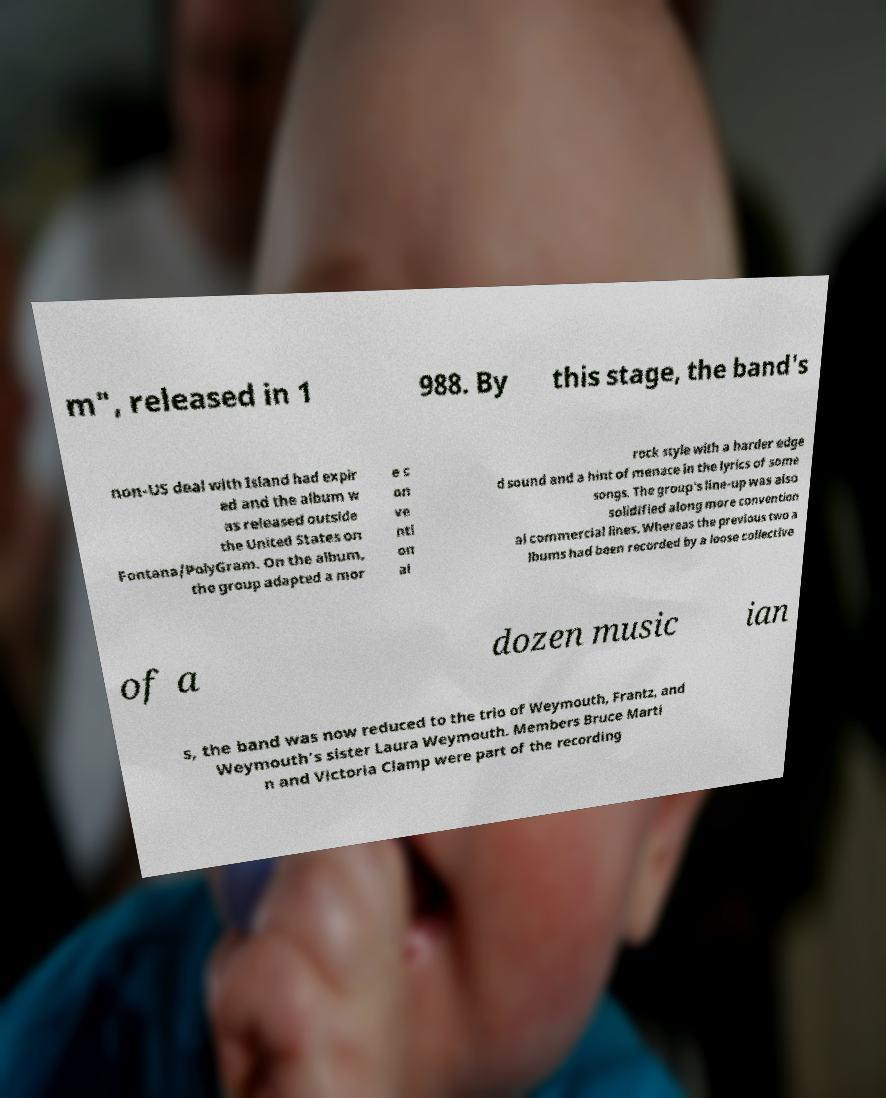I need the written content from this picture converted into text. Can you do that? m", released in 1 988. By this stage, the band's non-US deal with Island had expir ed and the album w as released outside the United States on Fontana/PolyGram. On the album, the group adapted a mor e c on ve nti on al rock style with a harder edge d sound and a hint of menace in the lyrics of some songs. The group's line-up was also solidified along more convention al commercial lines. Whereas the previous two a lbums had been recorded by a loose collective of a dozen music ian s, the band was now reduced to the trio of Weymouth, Frantz, and Weymouth's sister Laura Weymouth. Members Bruce Marti n and Victoria Clamp were part of the recording 